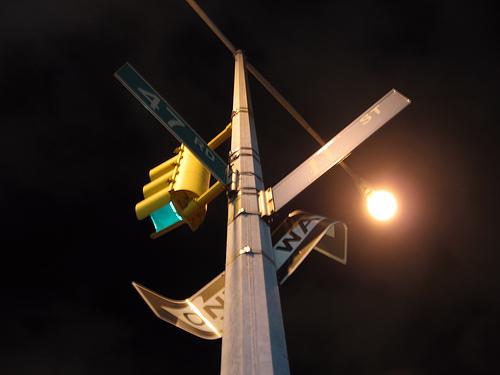Is the light on?
Quick response, please. Yes. Which sign is bent?
Short answer required. One way. Does the stoplight say go?
Give a very brief answer. Yes. 